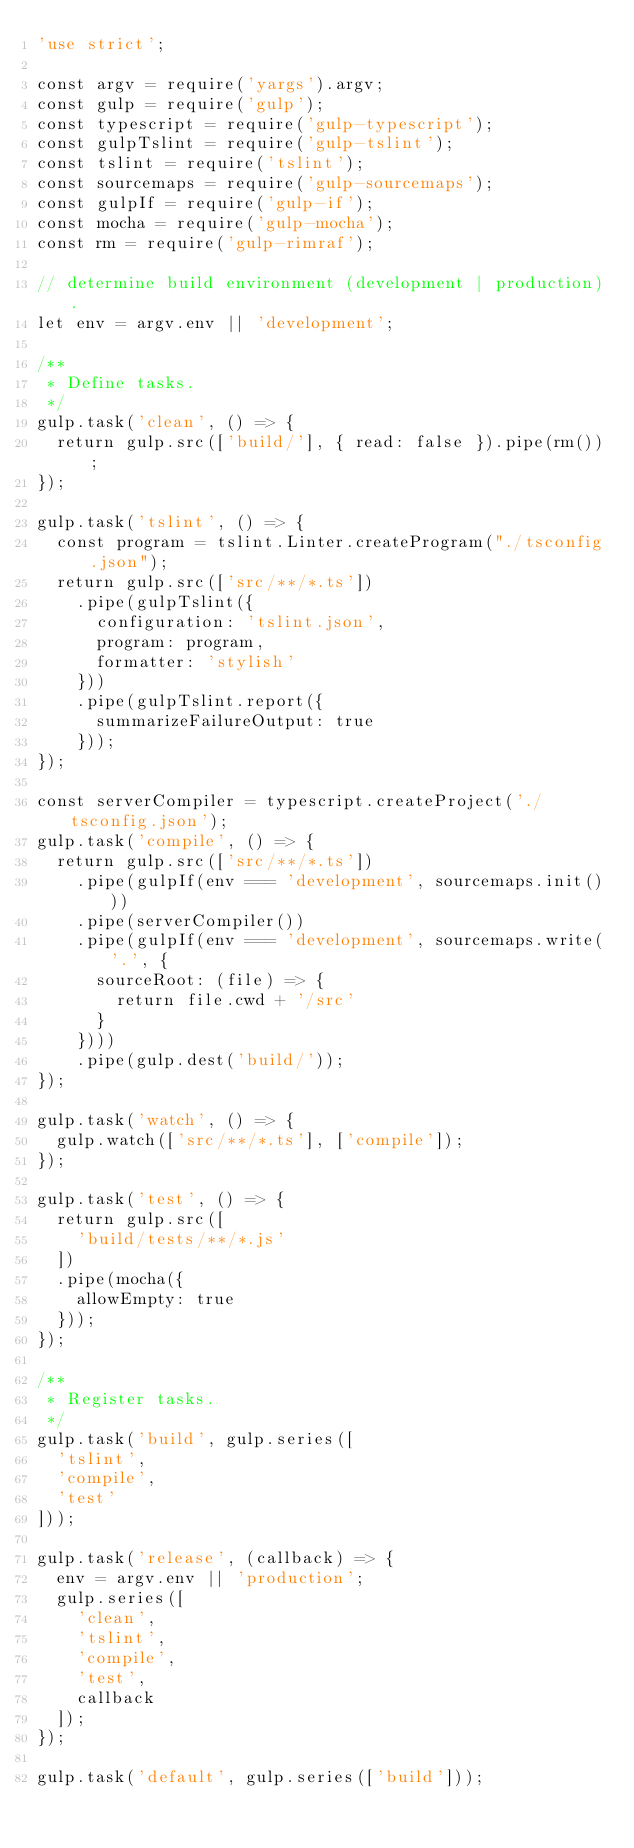<code> <loc_0><loc_0><loc_500><loc_500><_JavaScript_>'use strict';

const argv = require('yargs').argv;
const gulp = require('gulp');
const typescript = require('gulp-typescript');
const gulpTslint = require('gulp-tslint');
const tslint = require('tslint');
const sourcemaps = require('gulp-sourcemaps');
const gulpIf = require('gulp-if');
const mocha = require('gulp-mocha');
const rm = require('gulp-rimraf');

// determine build environment (development | production).
let env = argv.env || 'development';

/**
 * Define tasks.
 */
gulp.task('clean', () => {
  return gulp.src(['build/'], { read: false }).pipe(rm());
});

gulp.task('tslint', () => {
  const program = tslint.Linter.createProgram("./tsconfig.json");
  return gulp.src(['src/**/*.ts'])
    .pipe(gulpTslint({
      configuration: 'tslint.json',
      program: program,
      formatter: 'stylish'
    }))
    .pipe(gulpTslint.report({
      summarizeFailureOutput: true
    }));
});

const serverCompiler = typescript.createProject('./tsconfig.json');
gulp.task('compile', () => {
  return gulp.src(['src/**/*.ts'])
    .pipe(gulpIf(env === 'development', sourcemaps.init()))
    .pipe(serverCompiler())
    .pipe(gulpIf(env === 'development', sourcemaps.write('.', {
      sourceRoot: (file) => {
        return file.cwd + '/src'
      }
    })))
    .pipe(gulp.dest('build/'));
});

gulp.task('watch', () => {
  gulp.watch(['src/**/*.ts'], ['compile']);
});

gulp.task('test', () => {
  return gulp.src([
    'build/tests/**/*.js'
  ])
  .pipe(mocha({
    allowEmpty: true
  }));
});

/**
 * Register tasks.
 */
gulp.task('build', gulp.series([
  'tslint',
  'compile',
  'test'
]));

gulp.task('release', (callback) => {
  env = argv.env || 'production';
  gulp.series([
    'clean',
    'tslint',
    'compile',
    'test',
    callback
  ]);
});

gulp.task('default', gulp.series(['build']));
</code> 